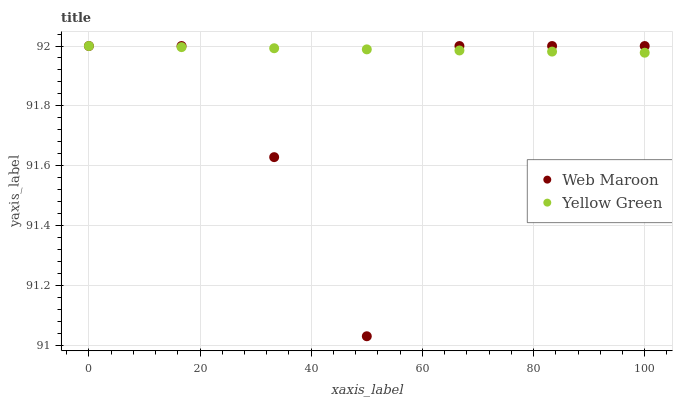Does Web Maroon have the minimum area under the curve?
Answer yes or no. Yes. Does Yellow Green have the maximum area under the curve?
Answer yes or no. Yes. Does Yellow Green have the minimum area under the curve?
Answer yes or no. No. Is Yellow Green the smoothest?
Answer yes or no. Yes. Is Web Maroon the roughest?
Answer yes or no. Yes. Is Yellow Green the roughest?
Answer yes or no. No. Does Web Maroon have the lowest value?
Answer yes or no. Yes. Does Yellow Green have the lowest value?
Answer yes or no. No. Does Yellow Green have the highest value?
Answer yes or no. Yes. Does Yellow Green intersect Web Maroon?
Answer yes or no. Yes. Is Yellow Green less than Web Maroon?
Answer yes or no. No. Is Yellow Green greater than Web Maroon?
Answer yes or no. No. 